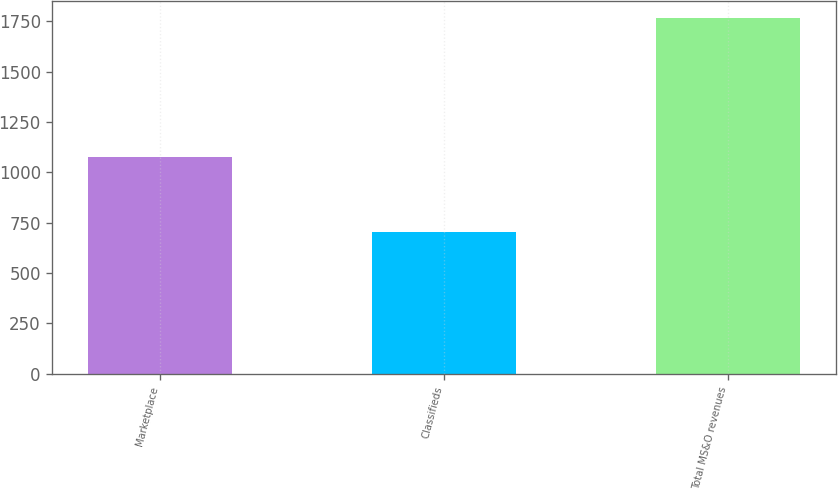Convert chart. <chart><loc_0><loc_0><loc_500><loc_500><bar_chart><fcel>Marketplace<fcel>Classifieds<fcel>Total MS&O revenues<nl><fcel>1078<fcel>703<fcel>1764<nl></chart> 